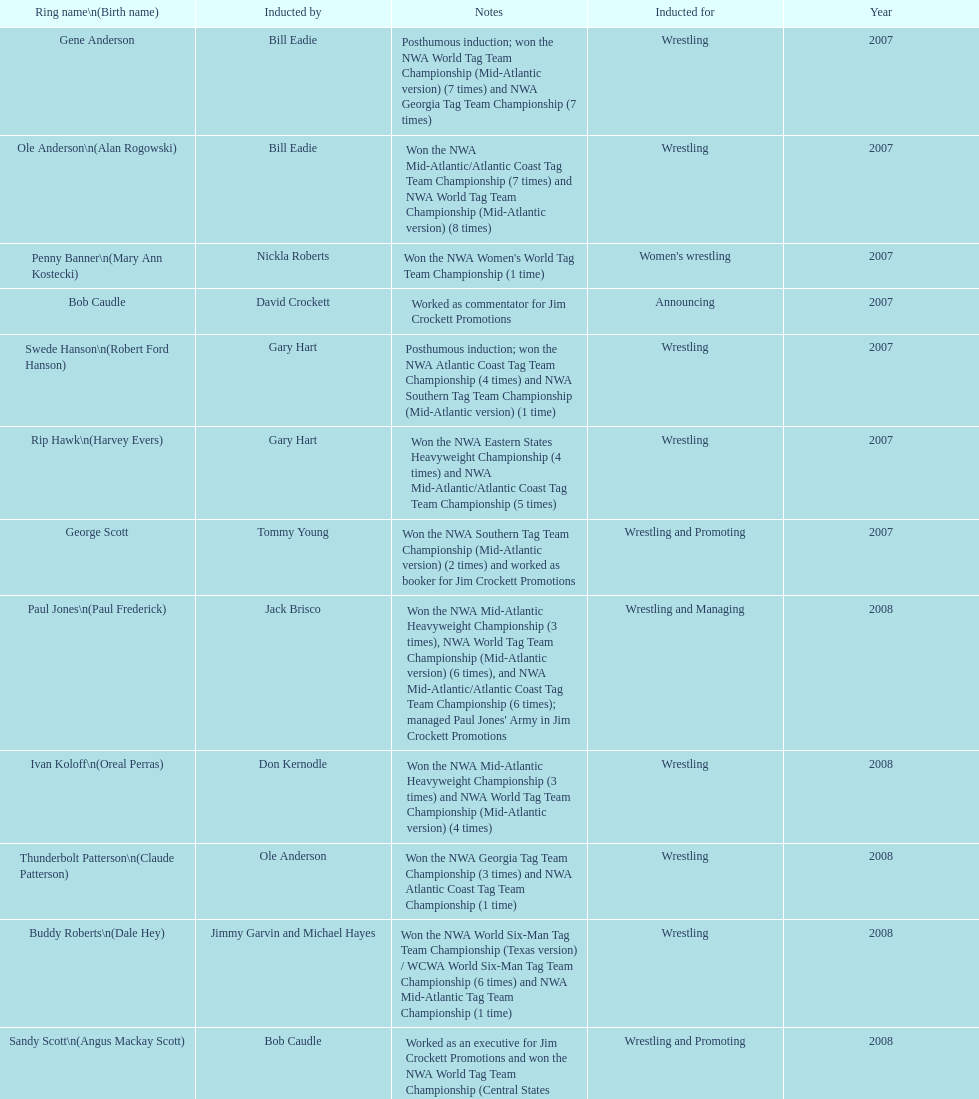Bob caudle was an announcer, who was the other one? Lance Russell. 